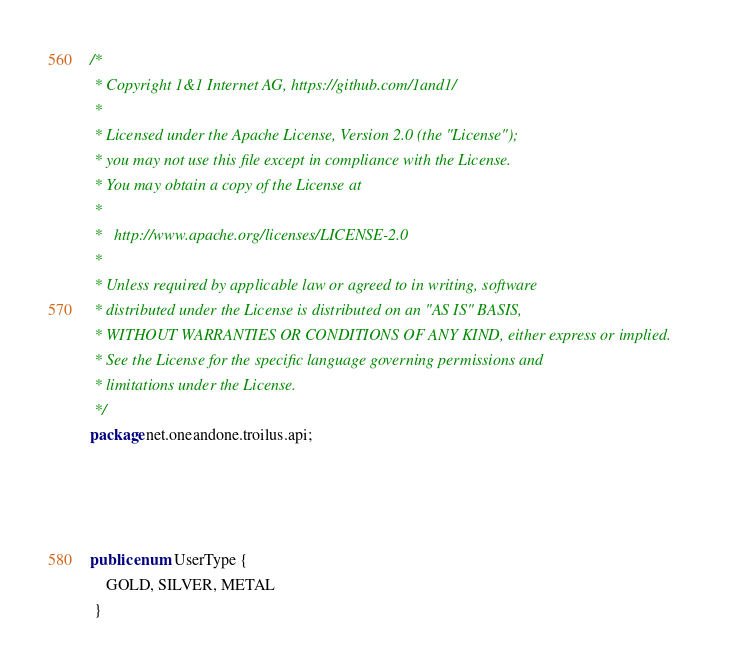Convert code to text. <code><loc_0><loc_0><loc_500><loc_500><_Java_>/*
 * Copyright 1&1 Internet AG, https://github.com/1and1/
 * 
 * Licensed under the Apache License, Version 2.0 (the "License");
 * you may not use this file except in compliance with the License.
 * You may obtain a copy of the License at
 *
 *   http://www.apache.org/licenses/LICENSE-2.0
 *
 * Unless required by applicable law or agreed to in writing, software
 * distributed under the License is distributed on an "AS IS" BASIS,
 * WITHOUT WARRANTIES OR CONDITIONS OF ANY KIND, either express or implied.
 * See the License for the specific language governing permissions and
 * limitations under the License.
 */
package net.oneandone.troilus.api;




public enum UserType {
    GOLD, SILVER, METAL 
 }

</code> 